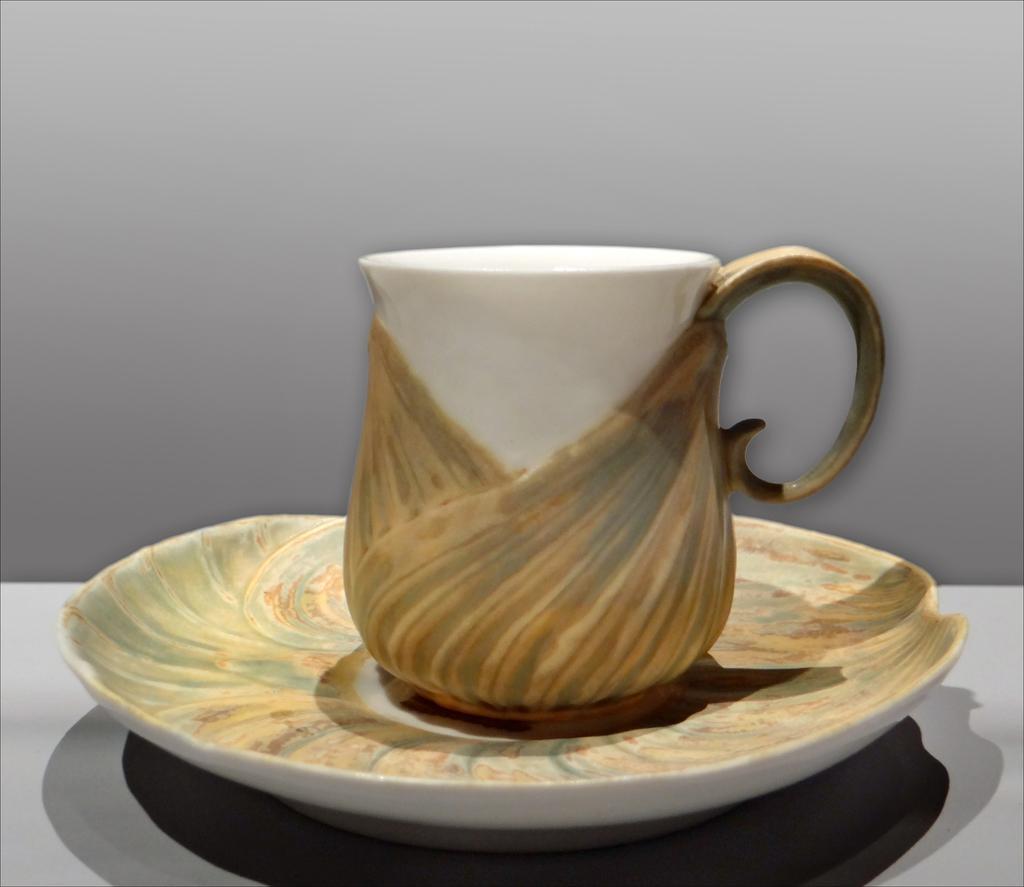Could you give a brief overview of what you see in this image? In this image I can see the cup and the saucer. The cup is in white and brown color and the saucer is also in brown color. It is on the white surface. In the background I can see the white wall. 